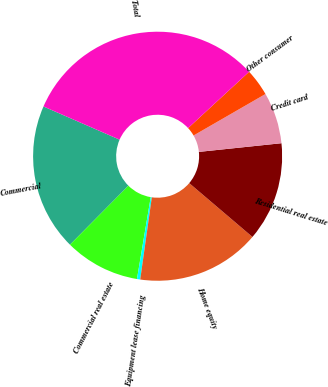Convert chart. <chart><loc_0><loc_0><loc_500><loc_500><pie_chart><fcel>Commercial<fcel>Commercial real estate<fcel>Equipment lease financing<fcel>Home equity<fcel>Residential real estate<fcel>Credit card<fcel>Other consumer<fcel>Total<nl><fcel>19.12%<fcel>9.77%<fcel>0.42%<fcel>16.01%<fcel>12.89%<fcel>6.66%<fcel>3.54%<fcel>31.59%<nl></chart> 